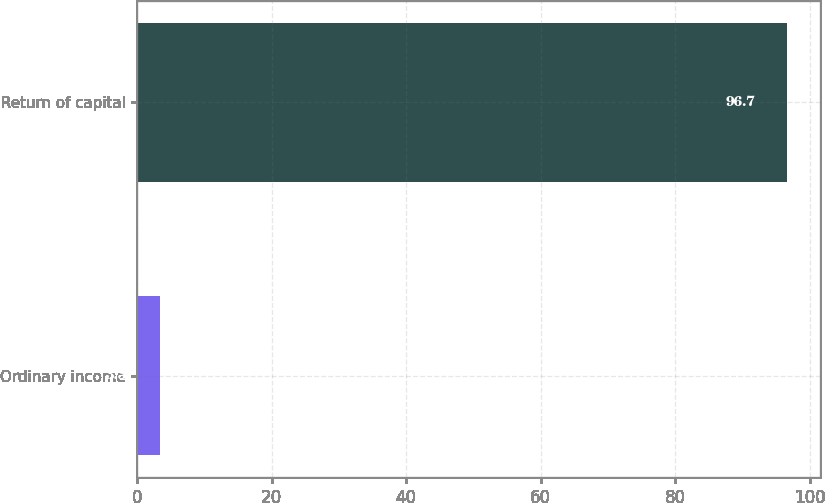Convert chart to OTSL. <chart><loc_0><loc_0><loc_500><loc_500><bar_chart><fcel>Ordinary income<fcel>Return of capital<nl><fcel>3.3<fcel>96.7<nl></chart> 